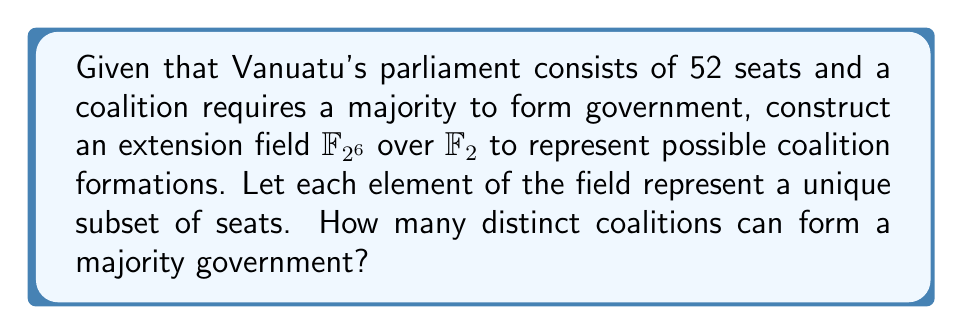What is the answer to this math problem? 1) First, we construct the extension field $\mathbb{F}_{2^6}$ over $\mathbb{F}_2$. This field has $2^6 = 64$ elements, which is sufficient to represent all possible subsets of the 52 seats (as $2^{52}$ would be too large).

2) Each element in $\mathbb{F}_{2^6}$ can be represented as a 6-bit binary number, corresponding to a unique subset of seats.

3) A majority in a 52-seat parliament requires at least 27 seats (as $\frac{52}{2} + 1 = 27$).

4) To count the number of coalitions with at least 27 seats, we need to sum the number of combinations for 27, 28, ..., up to 52 seats:

   $$\sum_{i=27}^{52} \binom{52}{i}$$

5) This sum can be calculated as:

   $$\binom{52}{27} + \binom{52}{28} + ... + \binom{52}{52}$$

6) Using the binomial theorem, we know that:

   $$\sum_{i=0}^{52} \binom{52}{i} = 2^{52}$$

7) Therefore, our sum is equal to:

   $$2^{52} - (\binom{52}{0} + \binom{52}{1} + ... + \binom{52}{26})$$

8) Calculating this value (which can be done using a computer due to the large numbers involved) gives us 2,251,798,717,443,069 distinct majority coalitions.
Answer: 2,251,798,717,443,069 